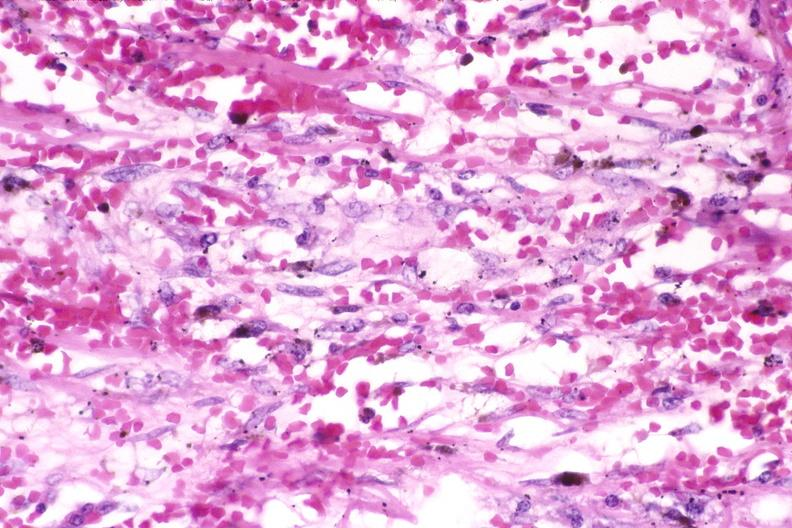where is this?
Answer the question using a single word or phrase. Skin 